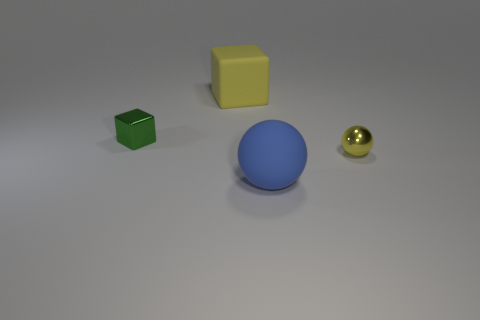Add 1 blue rubber objects. How many objects exist? 5 Subtract 0 cyan cylinders. How many objects are left? 4 Subtract all rubber objects. Subtract all yellow matte spheres. How many objects are left? 2 Add 4 yellow metal balls. How many yellow metal balls are left? 5 Add 3 small yellow spheres. How many small yellow spheres exist? 4 